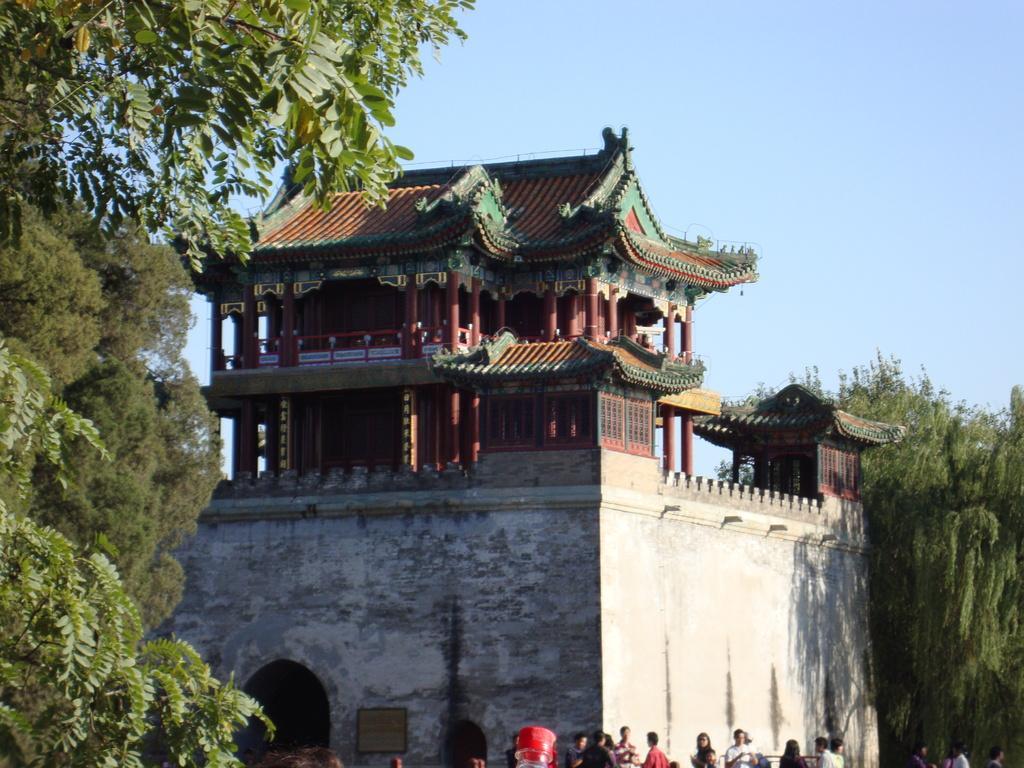How would you summarize this image in a sentence or two? In this image there is the sky truncated towards the top of the image, there is the building, there is the wall, there is tree truncated towards the right of the image, there are trees truncated towards the left of the image, there is tree truncated towards the top of the image, there is an object truncated towards the bottom of the image, there are persons truncated towards the bottom of the image. 